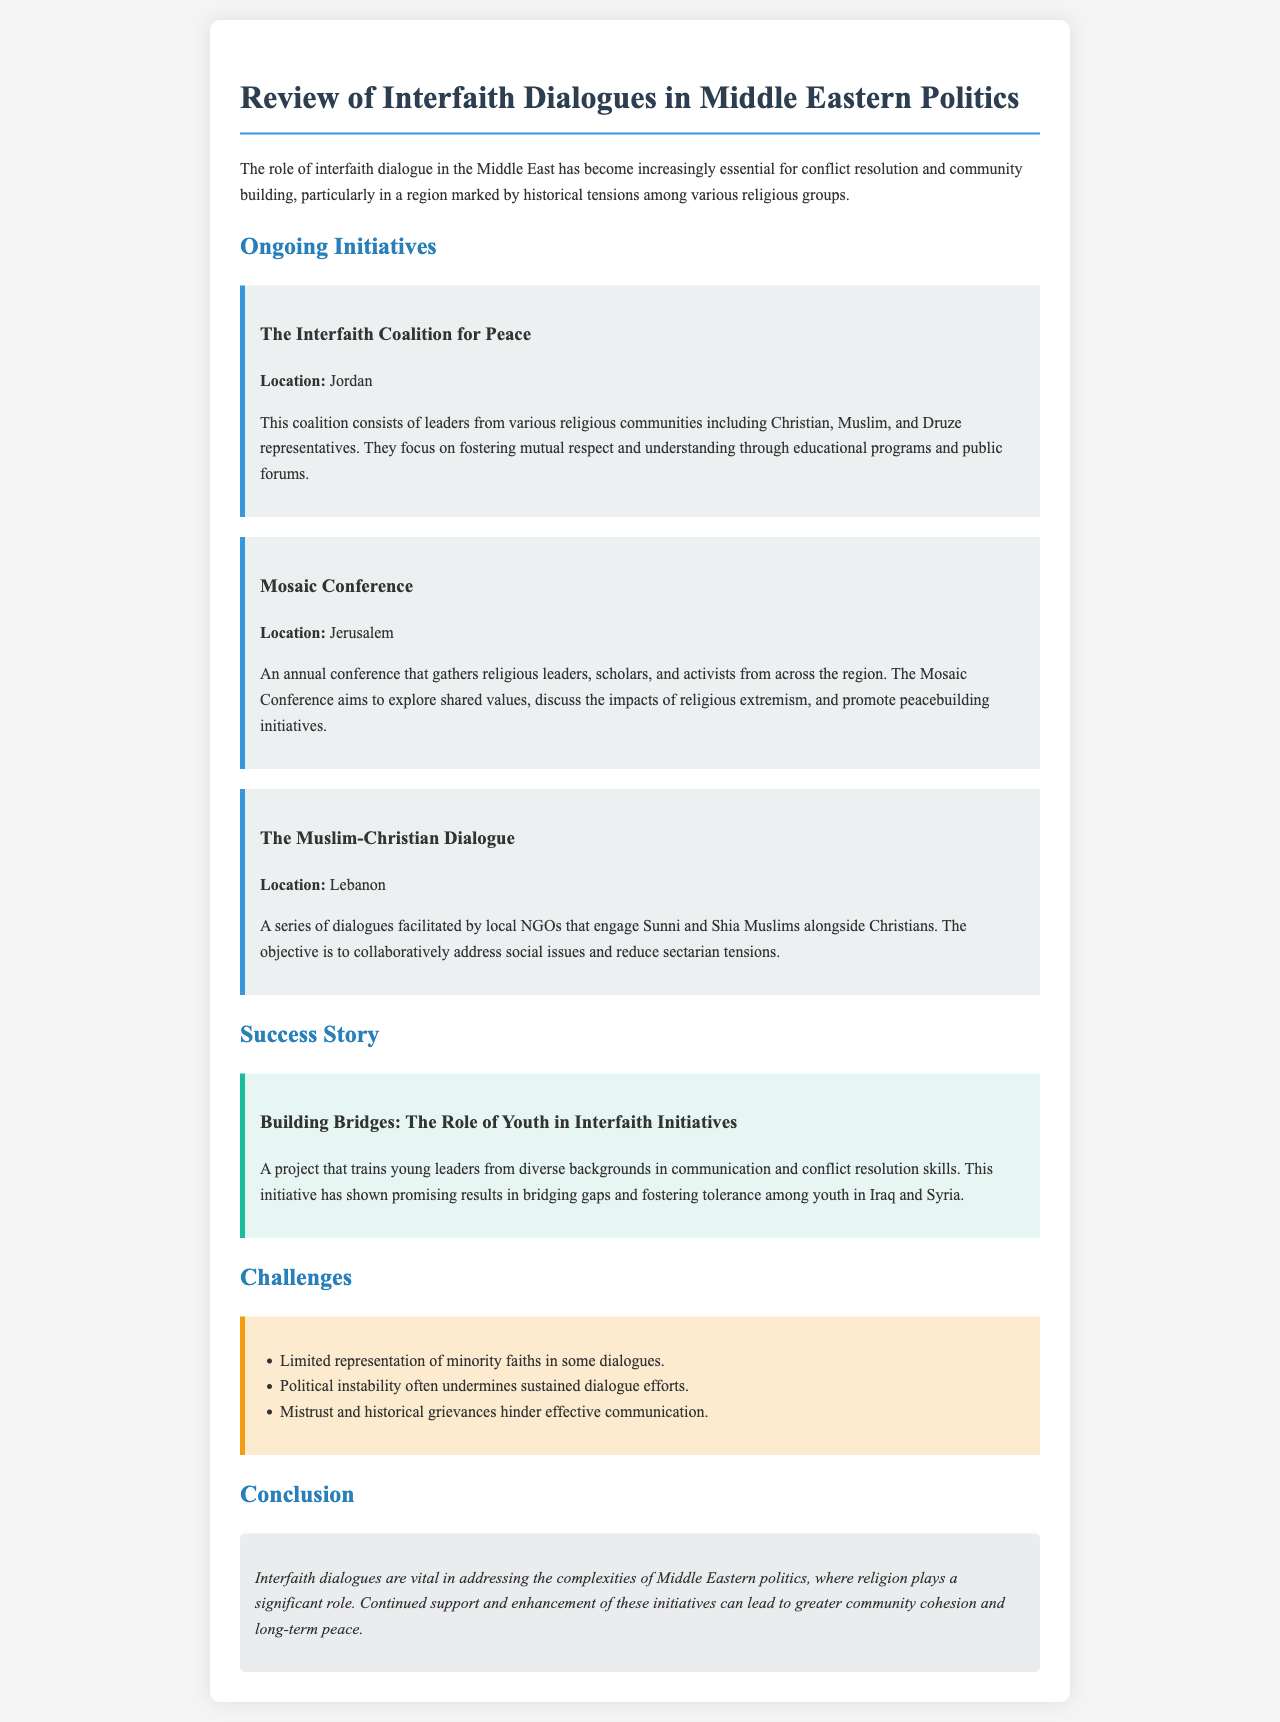What is the title of the document? The title is the main heading that identifies the content of the document.
Answer: Review of Interfaith Dialogues in Middle Eastern Politics Where is the Interfaith Coalition for Peace located? The location is explicitly mentioned in the section describing the ongoing initiatives.
Answer: Jordan What is the primary goal of the Mosaic Conference? This goal is outlined in the description of the conference's purpose within the initiatives.
Answer: Promote peacebuilding initiatives What specific challenges are noted in the document? The challenges are listed in a bulleted format, referring to issues impacting interfaith dialogue.
Answer: Limited representation of minority faiths in some dialogues Which country is highlighted for facilitating Muslim-Christian dialogues? The country is clearly indicated in the initiative description related to these dialogues.
Answer: Lebanon What role do youth play in interfaith initiatives according to the success story? The role is described in the success story section detailing the impact of young leaders.
Answer: Building Bridges How many ongoing initiatives are mentioned in the document? The number of initiatives can be counted from the initiatives section.
Answer: Three What is emphasized as vital in the conclusion of the document? This emphasis is summarized in the concluding remarks regarding interfaith dialogues.
Answer: Community cohesion 